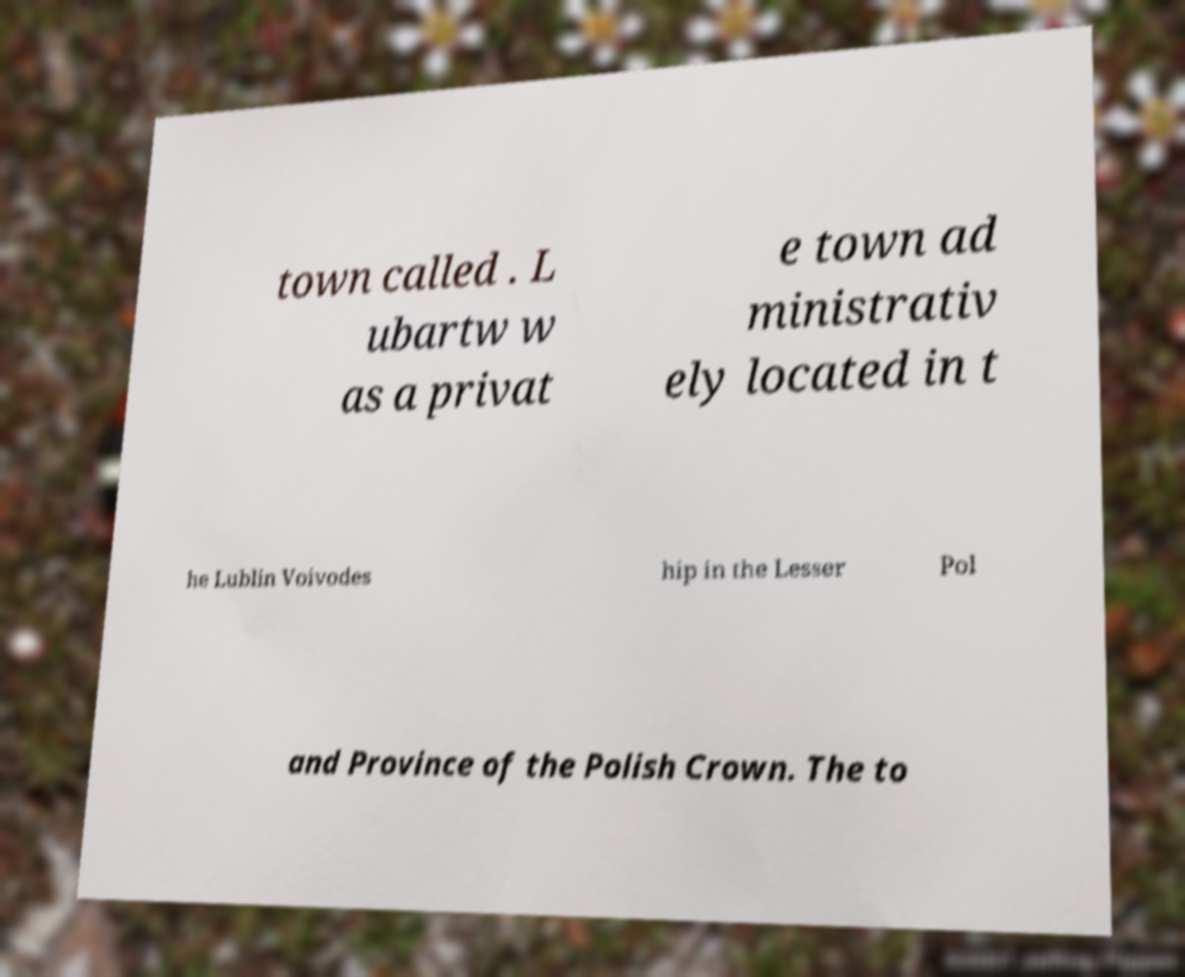What messages or text are displayed in this image? I need them in a readable, typed format. town called . L ubartw w as a privat e town ad ministrativ ely located in t he Lublin Voivodes hip in the Lesser Pol and Province of the Polish Crown. The to 